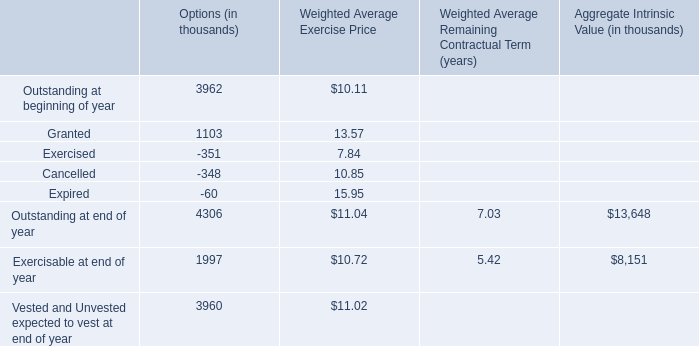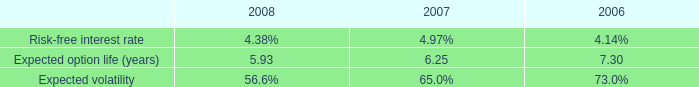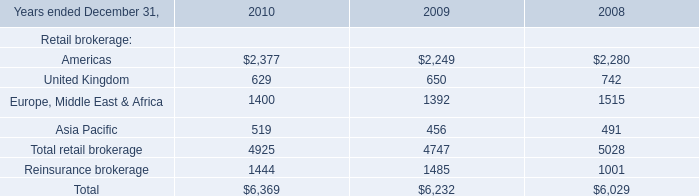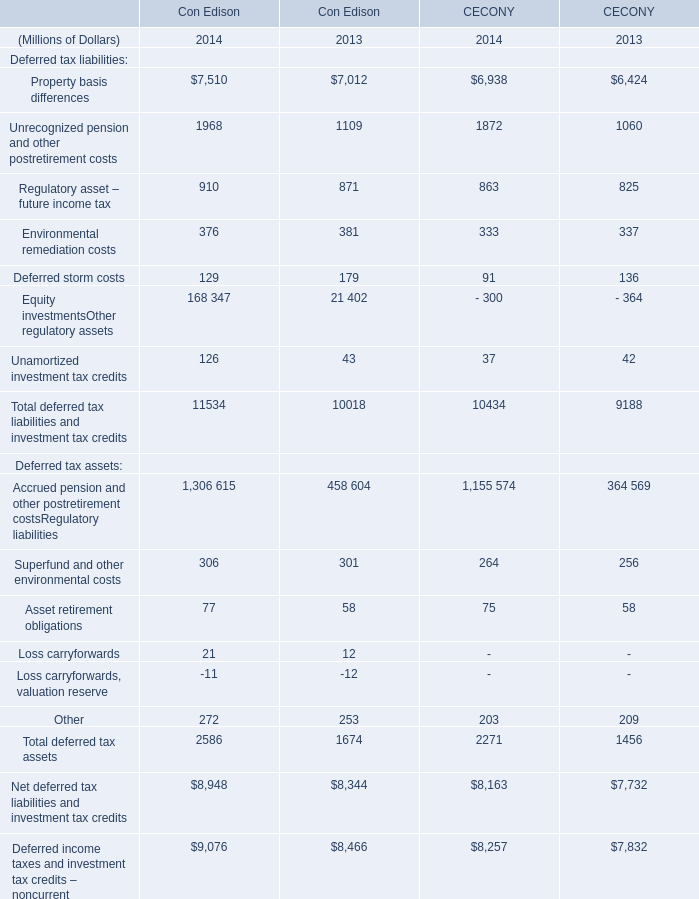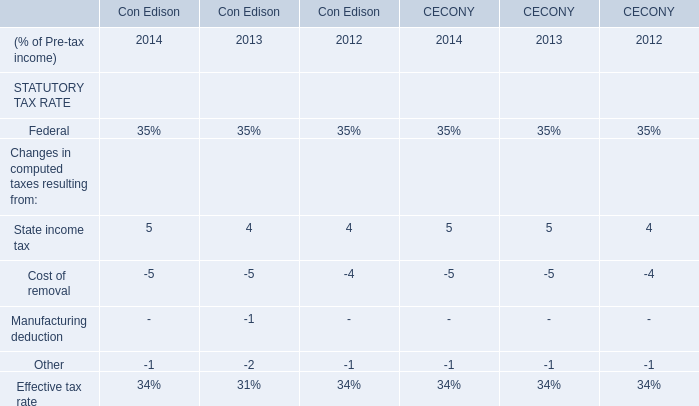What is the average growth rate of Net deferred tax liabilities and investment tax credits in terms of Con Edison between 2013 and 2014? 
Computations: ((8948 - 8344) / 8344)
Answer: 0.07239. 